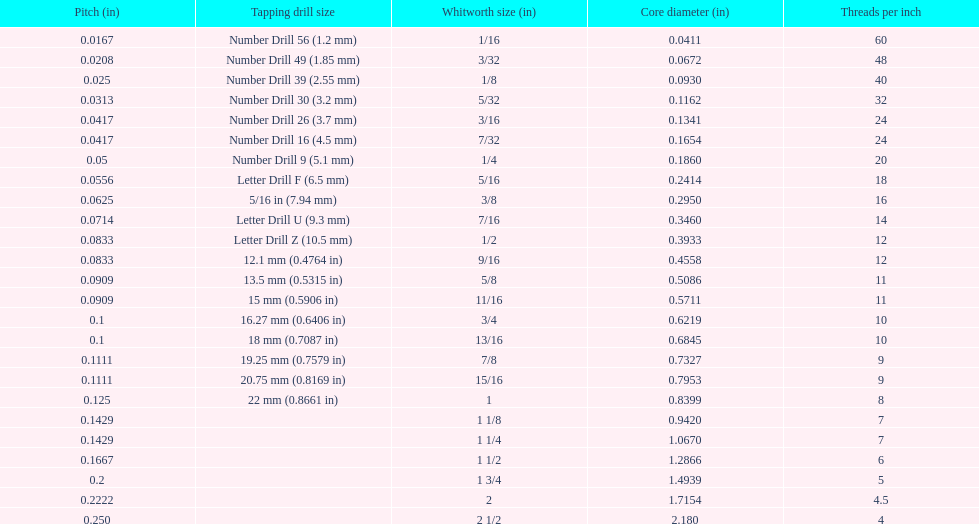What core diameter (in) comes after 0.0930? 0.1162. 